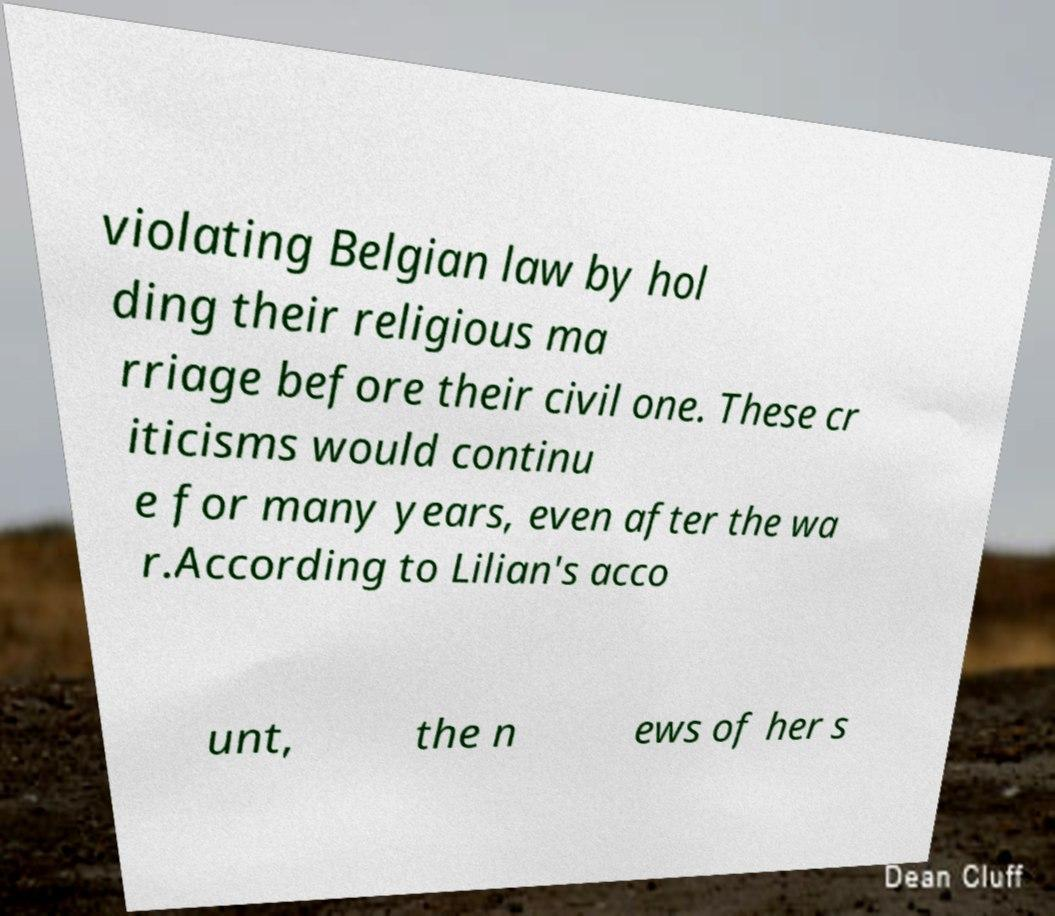Could you assist in decoding the text presented in this image and type it out clearly? violating Belgian law by hol ding their religious ma rriage before their civil one. These cr iticisms would continu e for many years, even after the wa r.According to Lilian's acco unt, the n ews of her s 